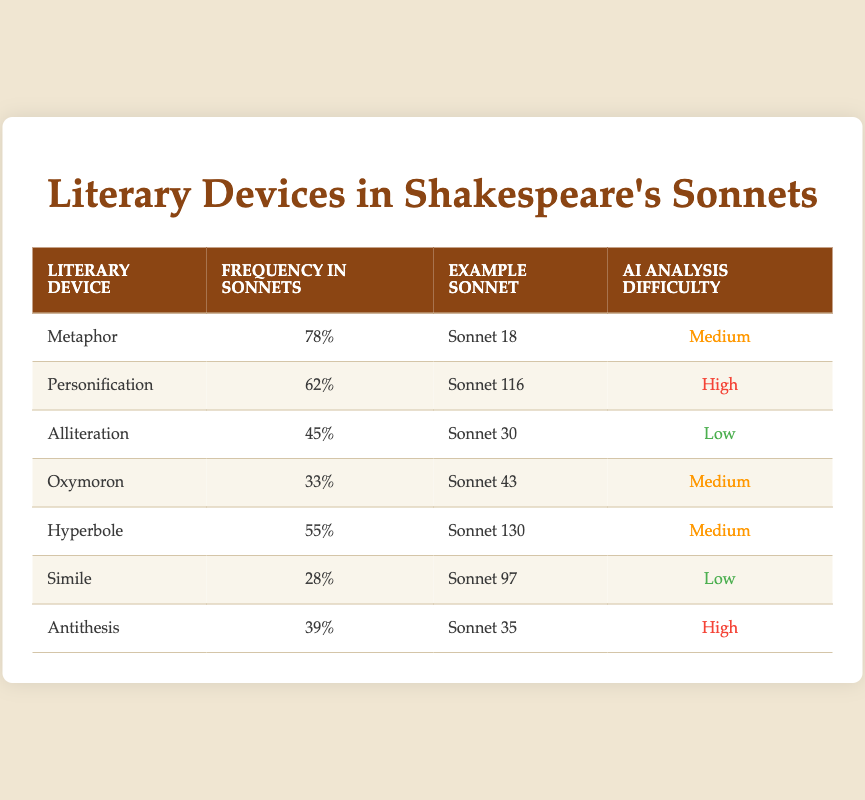What is the frequency of metaphor in Shakespeare's sonnets? The table shows that the frequency of metaphor is listed as 78% under the "Frequency in Sonnets" column.
Answer: 78% Which sonnet contains the example of personification? The table lists Sonnet 116 as the example for personification under the "Example Sonnet" column corresponding to the literary device.
Answer: Sonnet 116 How many literary devices have a frequency above 50%? Looking at the "Frequency in Sonnets" column, metaphor (78%), personification (62%), and hyperbole (55%) exceed 50%. Hence, there are three devices.
Answer: 3 Is simile the literary device with the lowest frequency in sonnets? The table indicates that simile has a frequency of 28%, which is lower than all other devices listed.
Answer: Yes What is the average frequency of alliteration and antithesis in Shakespeare’s sonnets? Alliteration has a frequency of 45%, and antithesis has a frequency of 39%. We sum these values: 45% + 39% = 84%, then divide by 2 to find the average: 84% / 2 = 42%.
Answer: 42% Which literary device is the most difficult for AI analysis and what is its frequency? The most difficult for AI analysis is personification, with a frequency of 62%. This is found by identifying the highest difficulty (classed as high) in the "AI Analysis Difficulty" column and checking the corresponding frequency.
Answer: 62% How does the frequency of oxymoron compare to hyperbole? Oxymoron has a frequency of 33% and hyperbole has a frequency of 55%. To compare, hyperbole has a higher frequency than oxymoron by 55% - 33% = 22%.
Answer: Hyperbole is higher by 22% What percentage of literary devices listed have a high AI analysis difficulty rating? The table indicates there are 2 literary devices (personification and antithesis) rated as high difficulty out of a total of 7 devices. Thus, we calculate: (2/7) * 100 = approximately 28.57%.
Answer: 28.57% 